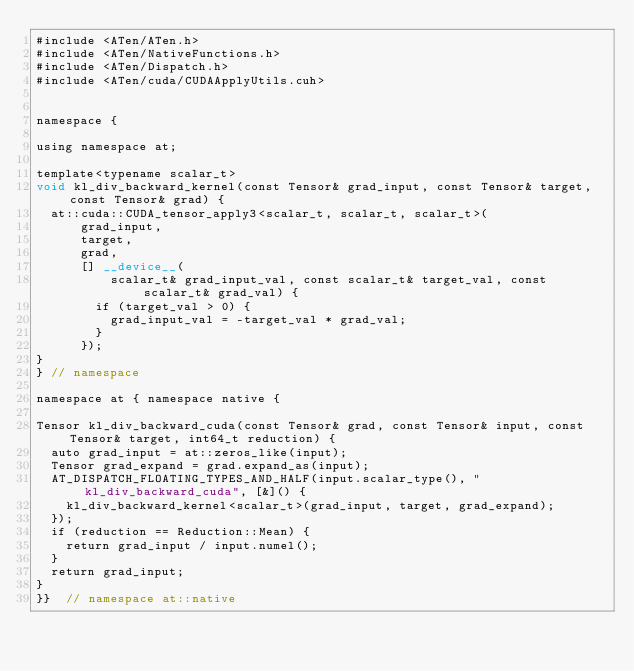Convert code to text. <code><loc_0><loc_0><loc_500><loc_500><_Cuda_>#include <ATen/ATen.h>
#include <ATen/NativeFunctions.h>
#include <ATen/Dispatch.h>
#include <ATen/cuda/CUDAApplyUtils.cuh>


namespace {

using namespace at;

template<typename scalar_t>
void kl_div_backward_kernel(const Tensor& grad_input, const Tensor& target, const Tensor& grad) {
  at::cuda::CUDA_tensor_apply3<scalar_t, scalar_t, scalar_t>(
      grad_input,
      target,
      grad,
      [] __device__(
          scalar_t& grad_input_val, const scalar_t& target_val, const scalar_t& grad_val) {
        if (target_val > 0) {
          grad_input_val = -target_val * grad_val;
        }
      });
}
} // namespace

namespace at { namespace native {

Tensor kl_div_backward_cuda(const Tensor& grad, const Tensor& input, const Tensor& target, int64_t reduction) {
  auto grad_input = at::zeros_like(input);
  Tensor grad_expand = grad.expand_as(input);
  AT_DISPATCH_FLOATING_TYPES_AND_HALF(input.scalar_type(), "kl_div_backward_cuda", [&]() {
    kl_div_backward_kernel<scalar_t>(grad_input, target, grad_expand);
  });
  if (reduction == Reduction::Mean) {
    return grad_input / input.numel();
  }
  return grad_input;
}
}}  // namespace at::native
</code> 